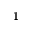Convert formula to latex. <formula><loc_0><loc_0><loc_500><loc_500>1</formula> 